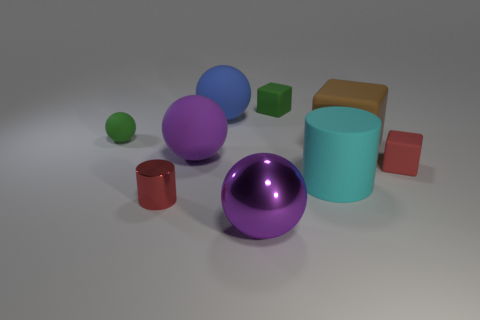What number of big things are to the right of the blue rubber object and in front of the brown thing?
Make the answer very short. 2. What number of objects are either large red blocks or big objects behind the small metal object?
Give a very brief answer. 4. Are there more big gray shiny spheres than big blue rubber things?
Provide a succinct answer. No. The red object that is behind the cyan matte cylinder has what shape?
Make the answer very short. Cube. What number of red metal objects have the same shape as the big brown rubber object?
Make the answer very short. 0. How big is the cyan rubber cylinder that is right of the large purple object behind the large cyan cylinder?
Offer a very short reply. Large. How many purple objects are either big matte cylinders or matte spheres?
Your answer should be compact. 1. Are there fewer big blue rubber spheres that are on the right side of the matte cylinder than small red objects right of the purple metallic sphere?
Provide a succinct answer. Yes. There is a green cube; is it the same size as the brown rubber thing that is behind the big matte cylinder?
Offer a very short reply. No. How many purple objects have the same size as the red metallic cylinder?
Your answer should be very brief. 0. 